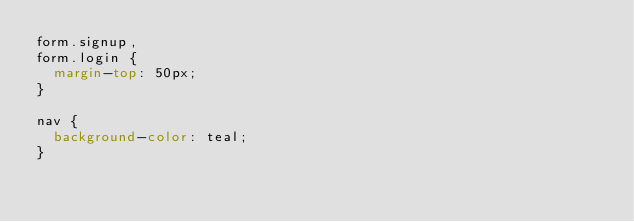Convert code to text. <code><loc_0><loc_0><loc_500><loc_500><_CSS_>form.signup,
form.login {
  margin-top: 50px;
}

nav {
  background-color: teal;
}
</code> 